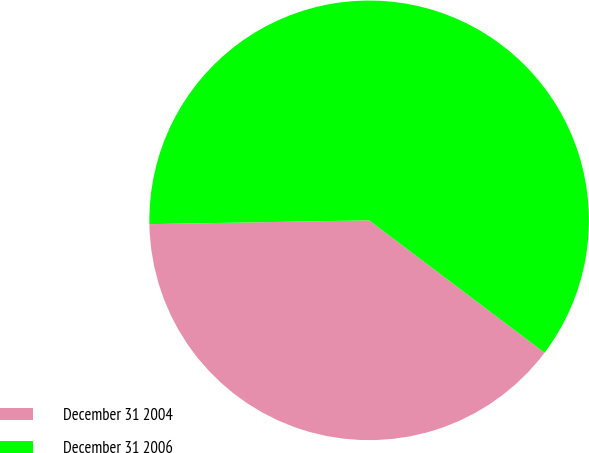Convert chart to OTSL. <chart><loc_0><loc_0><loc_500><loc_500><pie_chart><fcel>December 31 2004<fcel>December 31 2006<nl><fcel>39.43%<fcel>60.57%<nl></chart> 